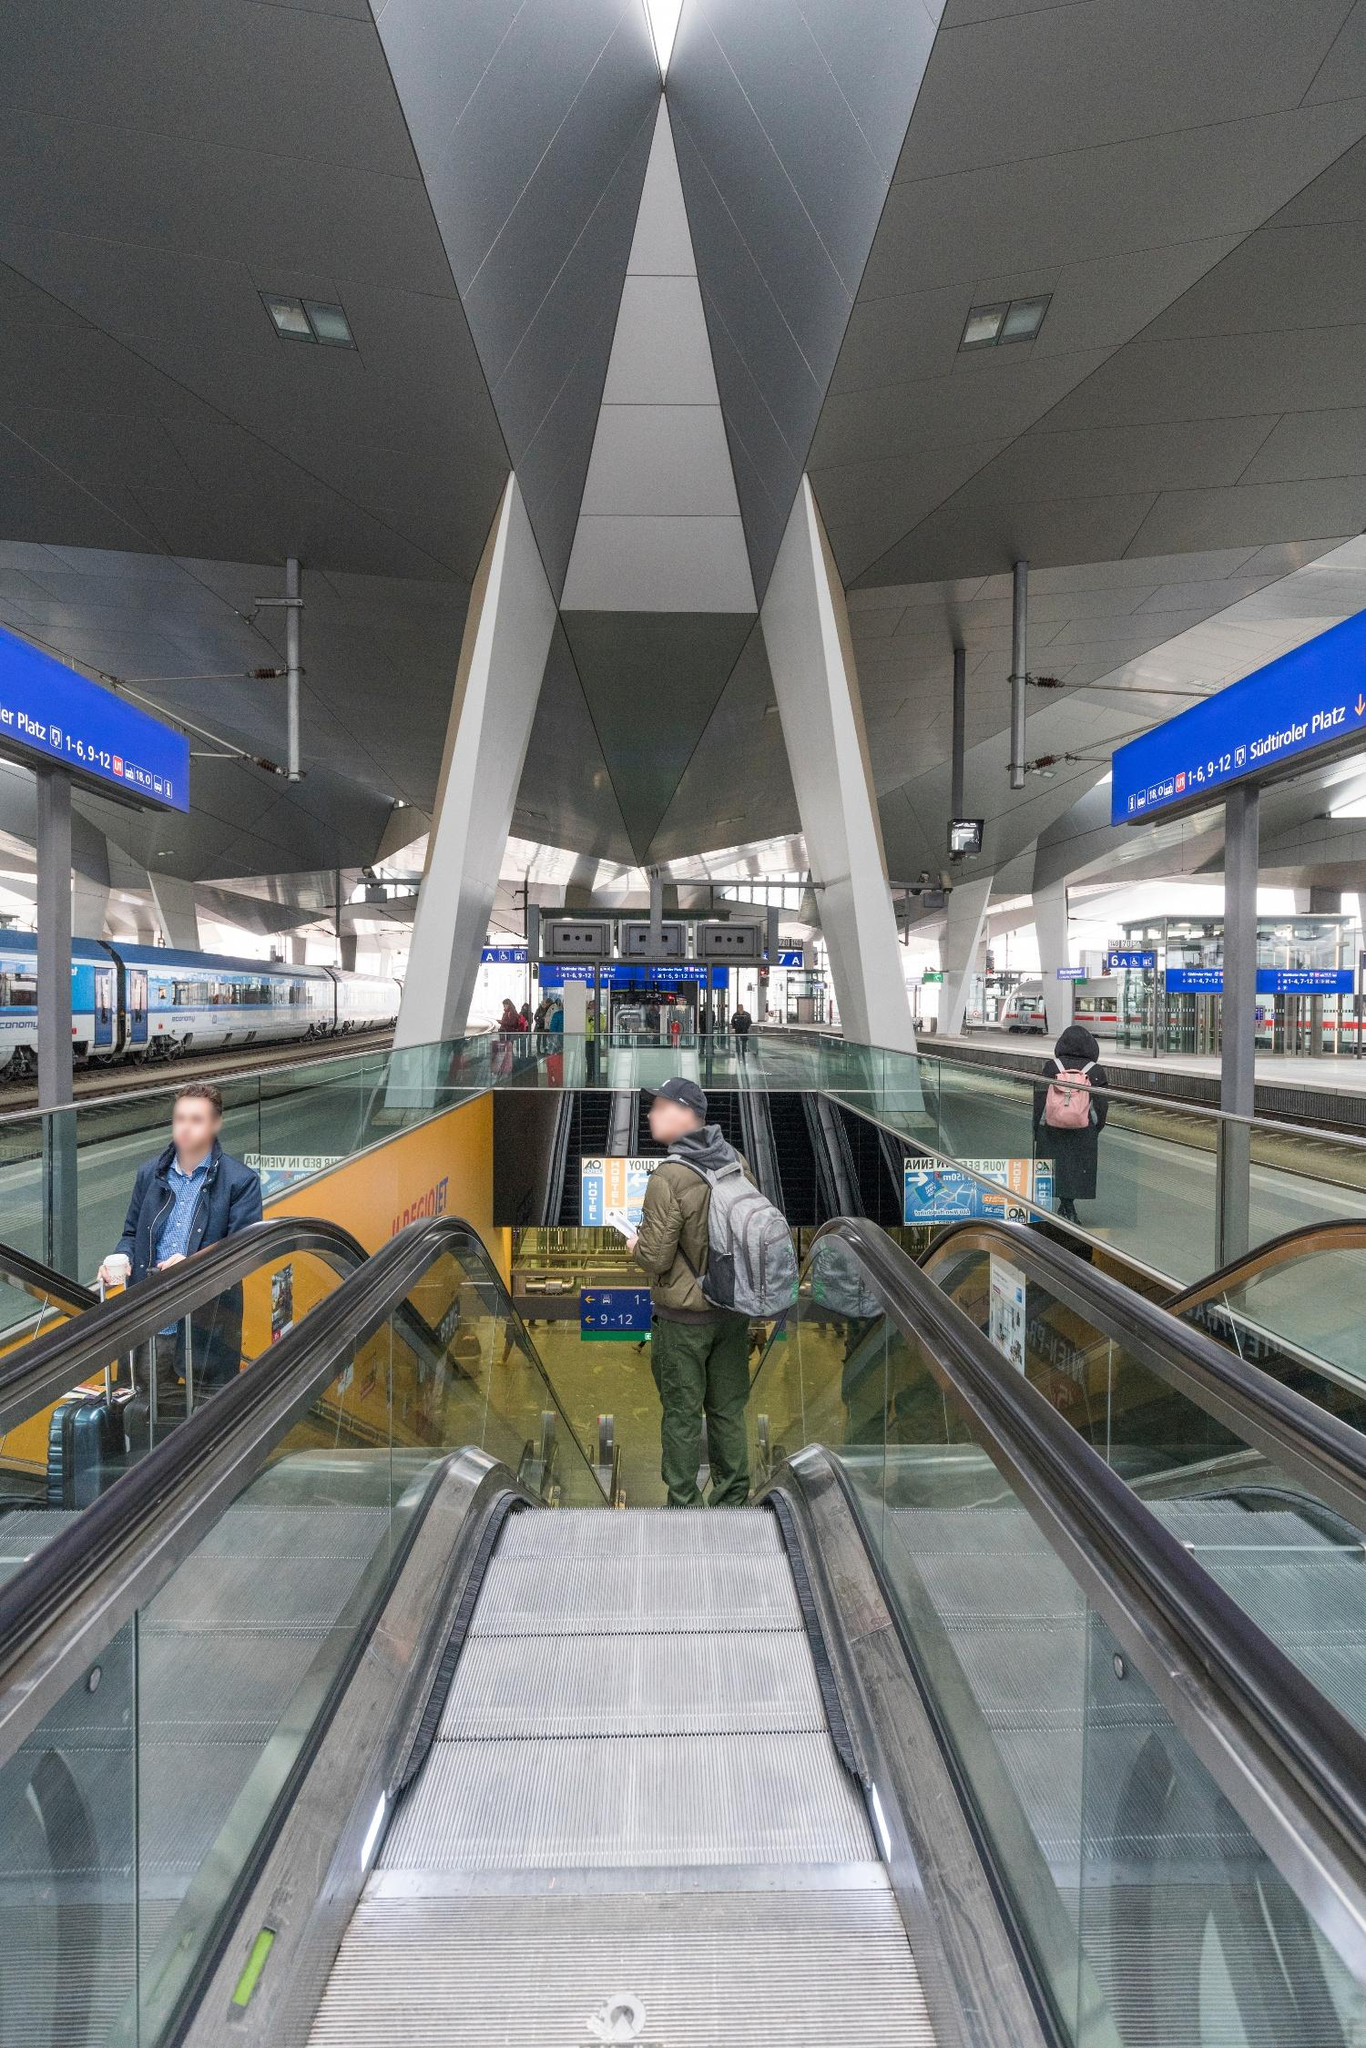What is this photo about'?
 The image captures the bustling atmosphere of a modern train station. From the vantage point at the top of an escalator, the viewer's gaze is drawn downwards towards the platform below. The escalator, a common feature in public transportation hubs, is framed by two large, triangular pillars. These pillars, with their gray color and metallic sheen, add a touch of industrial aesthetics to the scene.

The escalator leads to a platform adorned with blue signs, a universal color often associated with information and direction in public spaces. A train, the heart of any train station, can be seen in the background, ready to ferry passengers to their destinations.

Despite the grandeur of the architecture, the station is not devoid of human presence. A few people can be spotted on the escalator and platform, adding life to the otherwise mechanical environment. Their presence is a reminder that this space, while impressive in design, serves a practical purpose: to facilitate the movement of people from one place to another.

As for the landmark identification "sa_15897", I'm afraid I couldn't find any specific information related to this identifier in my current knowledge and search results. It might be a code specific to a certain database or system. If you have more context or information about this code, I might be able to provide a more accurate response. 